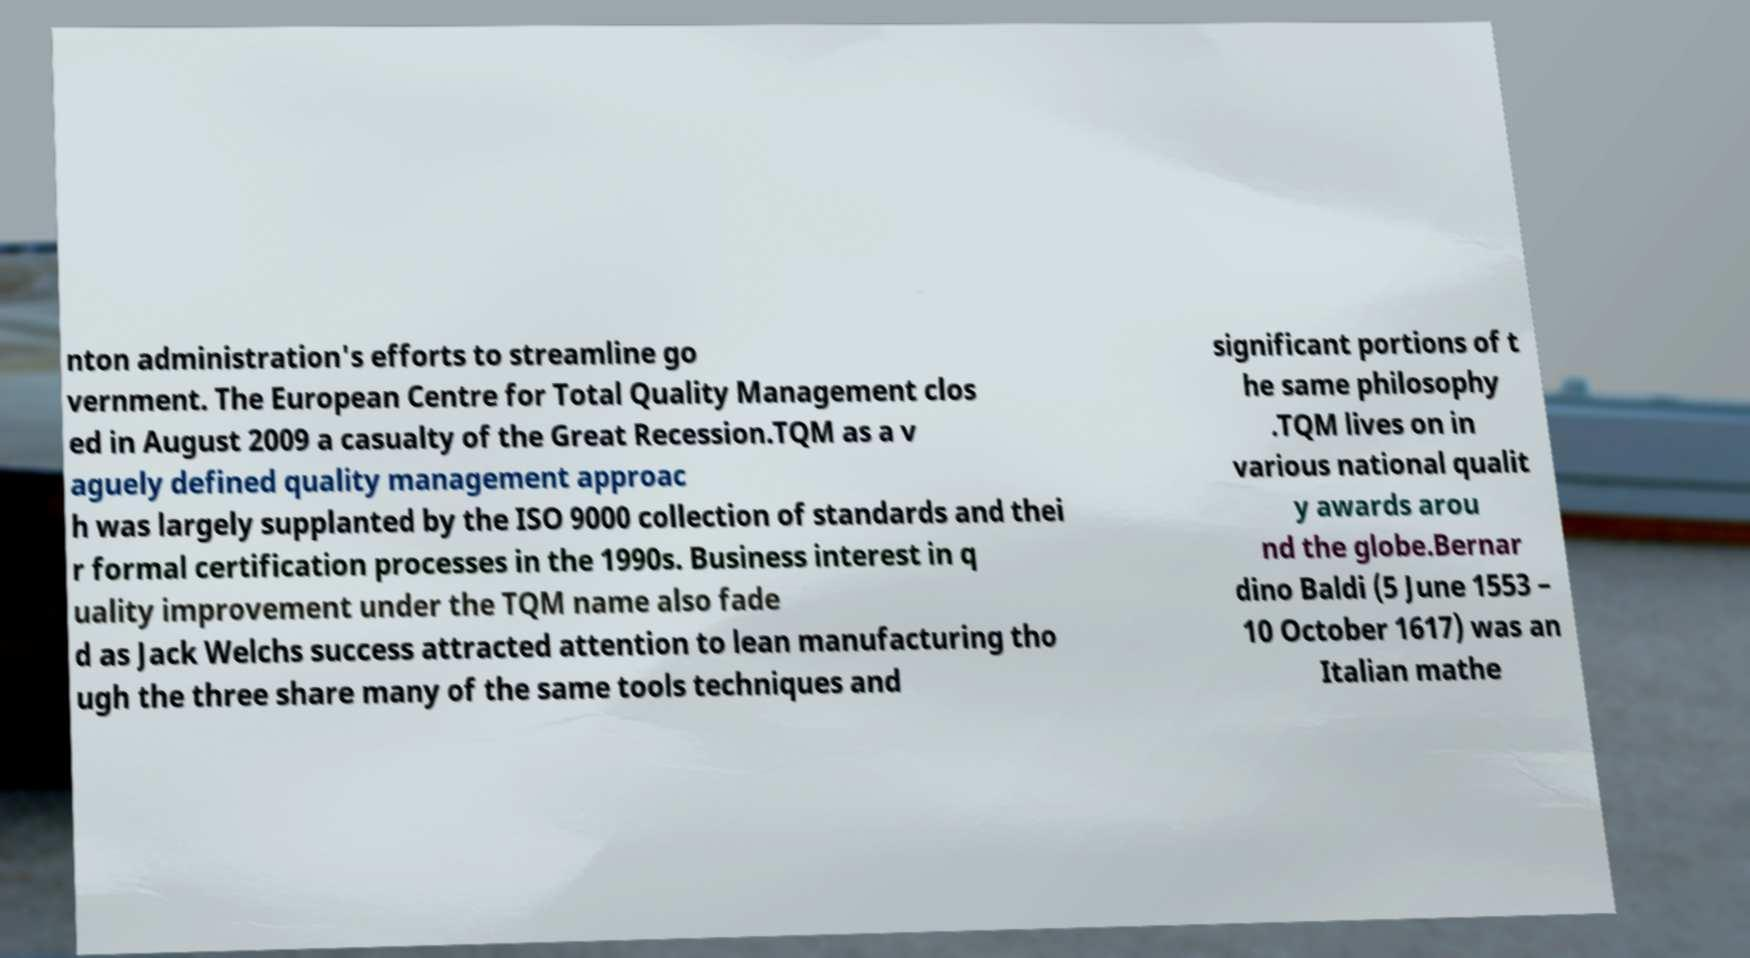For documentation purposes, I need the text within this image transcribed. Could you provide that? nton administration's efforts to streamline go vernment. The European Centre for Total Quality Management clos ed in August 2009 a casualty of the Great Recession.TQM as a v aguely defined quality management approac h was largely supplanted by the ISO 9000 collection of standards and thei r formal certification processes in the 1990s. Business interest in q uality improvement under the TQM name also fade d as Jack Welchs success attracted attention to lean manufacturing tho ugh the three share many of the same tools techniques and significant portions of t he same philosophy .TQM lives on in various national qualit y awards arou nd the globe.Bernar dino Baldi (5 June 1553 – 10 October 1617) was an Italian mathe 